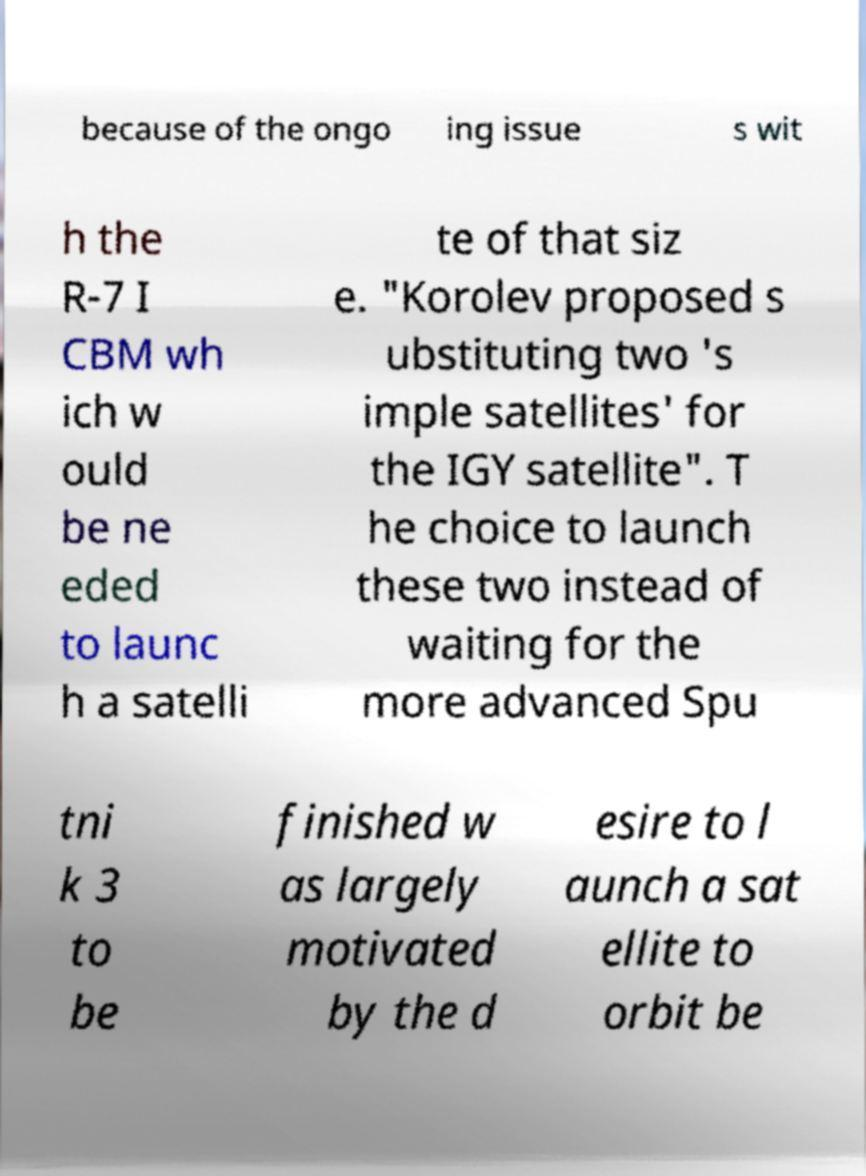Can you accurately transcribe the text from the provided image for me? because of the ongo ing issue s wit h the R-7 I CBM wh ich w ould be ne eded to launc h a satelli te of that siz e. "Korolev proposed s ubstituting two 's imple satellites' for the IGY satellite". T he choice to launch these two instead of waiting for the more advanced Spu tni k 3 to be finished w as largely motivated by the d esire to l aunch a sat ellite to orbit be 